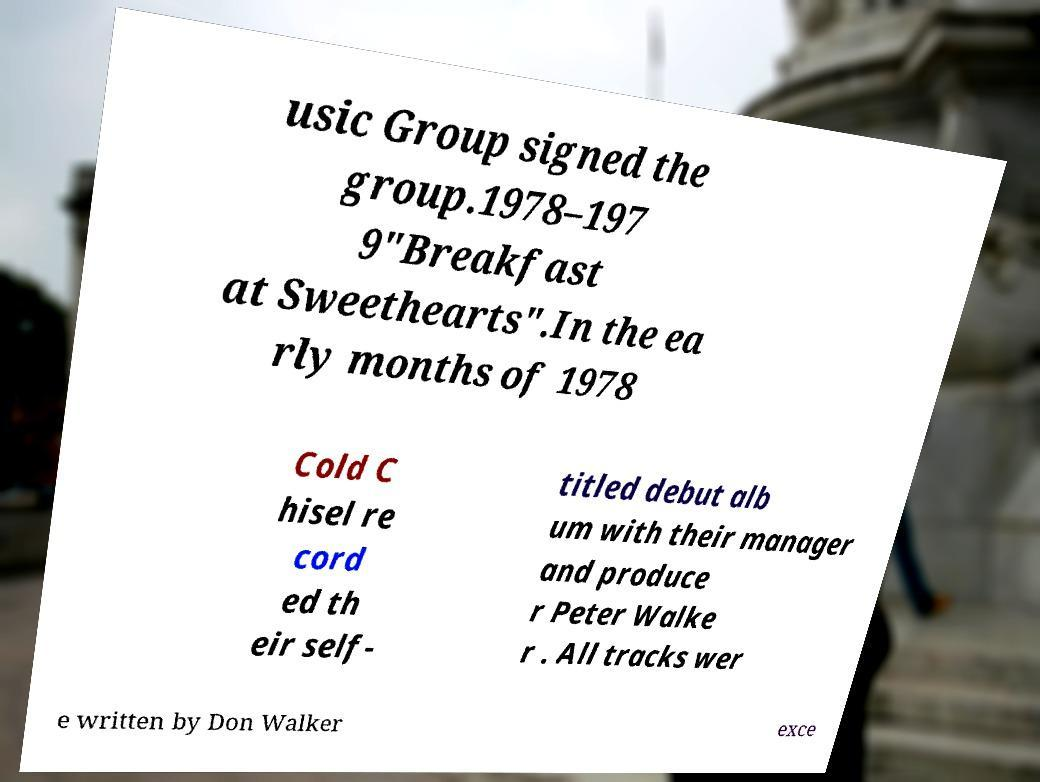Can you read and provide the text displayed in the image?This photo seems to have some interesting text. Can you extract and type it out for me? usic Group signed the group.1978–197 9"Breakfast at Sweethearts".In the ea rly months of 1978 Cold C hisel re cord ed th eir self- titled debut alb um with their manager and produce r Peter Walke r . All tracks wer e written by Don Walker exce 